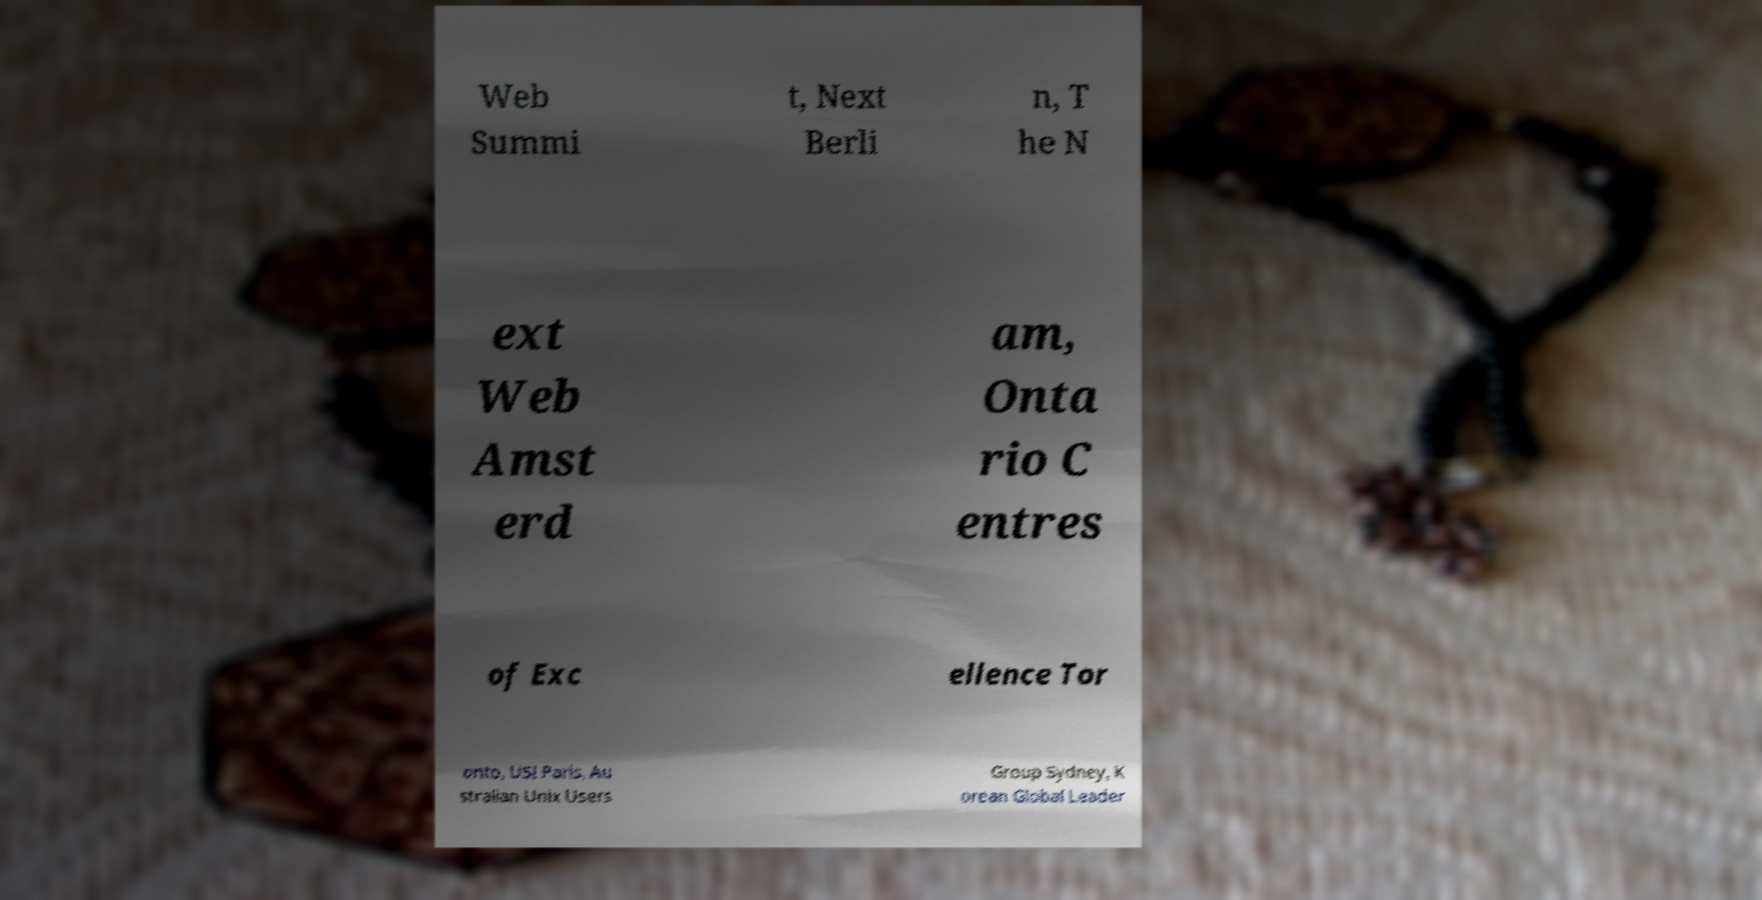Please read and relay the text visible in this image. What does it say? Web Summi t, Next Berli n, T he N ext Web Amst erd am, Onta rio C entres of Exc ellence Tor onto, USI Paris, Au stralian Unix Users Group Sydney, K orean Global Leader 